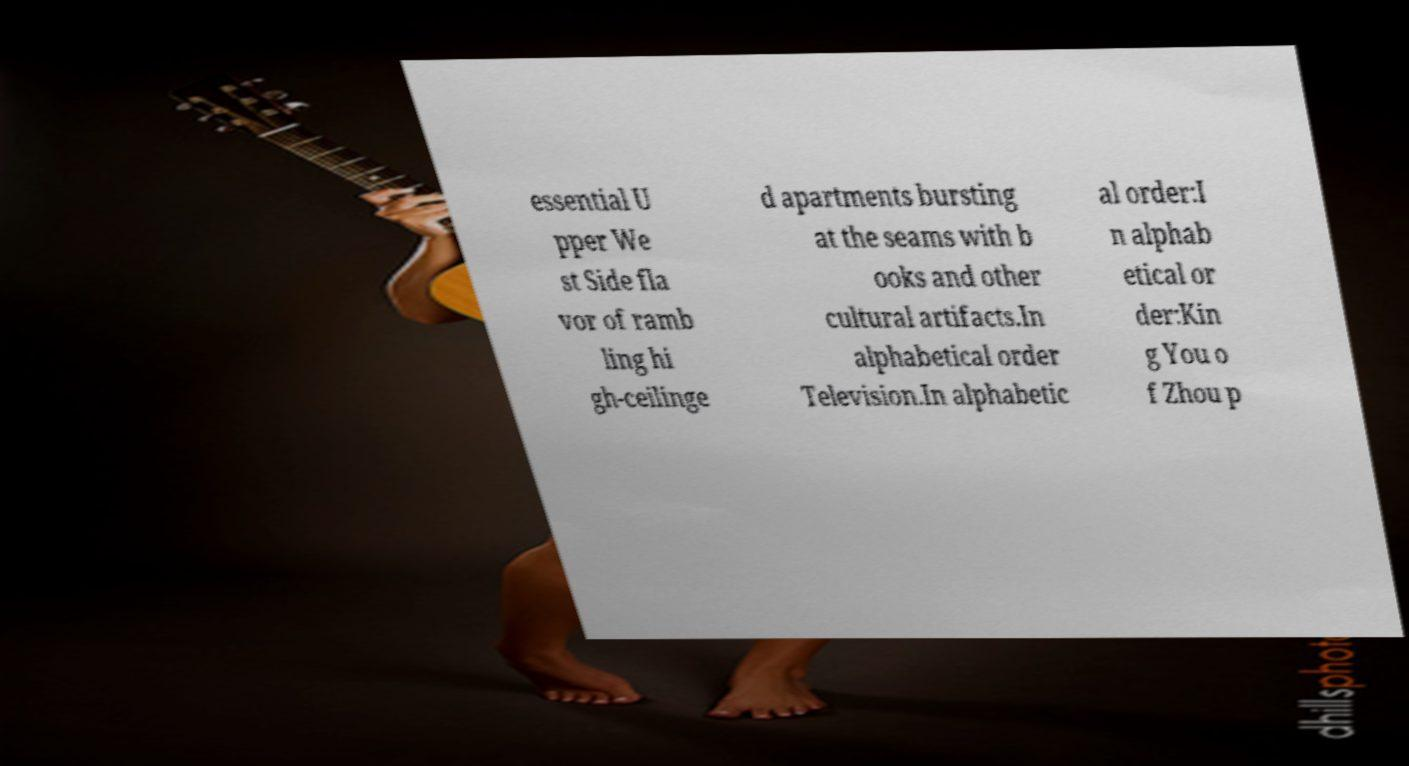For documentation purposes, I need the text within this image transcribed. Could you provide that? essential U pper We st Side fla vor of ramb ling hi gh-ceilinge d apartments bursting at the seams with b ooks and other cultural artifacts.In alphabetical order Television.In alphabetic al order:I n alphab etical or der:Kin g You o f Zhou p 